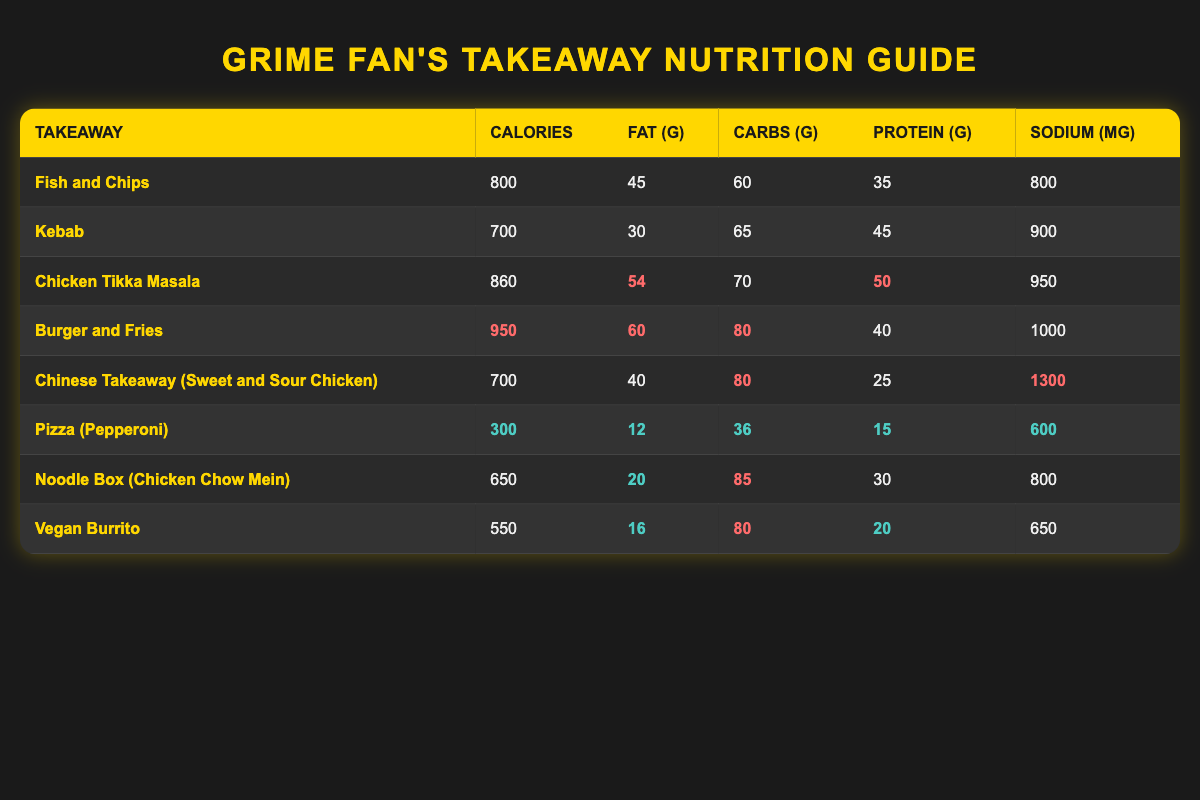What takeaway has the highest calories? By reviewing the "Calories" column, "Burger and Fries" has the highest value at 950 calories compared to the other options.
Answer: Burger and Fries What takeaway contains the lowest amount of fat? The "Fat (g)" column shows that "Pizza (Pepperoni)" has the lowest fat content at 12 grams when compared to all other takeaways.
Answer: Pizza (Pepperoni) Is the protein content of Chicken Tikka Masala higher than that of Fish and Chips? Comparing the "Protein (g)" values, Chicken Tikka Masala has 50 grams of protein, while Fish and Chips has 35 grams, confirming that Chicken Tikka Masala does indeed have more protein.
Answer: Yes What is the total carbohydrate content of both Kebab and Noodle Box? The "Carbohydrates (g)" for Kebab is 65 grams and for Noodle Box it is 85 grams. Adding these two values together results in 65 + 85 = 150 grams.
Answer: 150 grams Is there a takeaway that has more than 1000 mg of sodium? Looking at the "Sodium (mg)" column, both "Burger and Fries" (1000 mg) and "Chinese Takeaway (Sweet and Sour Chicken)" (1300 mg) exceed 1000 mg. Therefore, there are indeed takeaways with more sodium than 1000 mg.
Answer: Yes What is the average calorie count of the vegan options listed? The only vegan option is "Vegan Burrito", which has 550 calories. Since there's just one entry, the average is simply 550.
Answer: 550 Which takeaway has the highest sodium content? The "Sodium (mg)" column reveals that "Chinese Takeaway (Sweet and Sour Chicken)" has the highest sodium content at 1300 mg compared to all other takeaways.
Answer: Chinese Takeaway (Sweet and Sour Chicken) How many grams of protein does the Pizza (Pepperoni) provide? The "Protein (g)" column shows that Pizza (Pepperoni) provides 15 grams of protein when referred directly from the table.
Answer: 15 grams What is the difference in calories between the highest and lowest calorie takeaway? The highest calorie takeaway is "Burger and Fries" at 950 calories and the lowest is "Pizza (Pepperoni)" at 300 calories. The difference is 950 - 300 = 650 calories.
Answer: 650 calories 